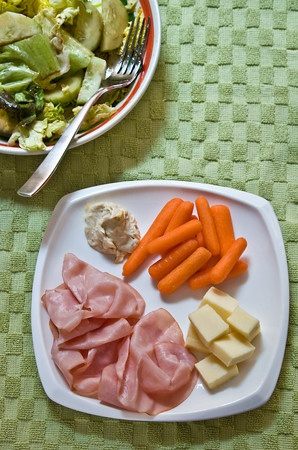Describe the objects in this image and their specific colors. I can see dining table in darkgray, olive, lightgray, and beige tones, fork in olive, lightgray, darkgray, black, and gray tones, carrot in olive, red, brown, and lavender tones, carrot in olive, red, brown, and salmon tones, and carrot in olive, red, brown, maroon, and salmon tones in this image. 